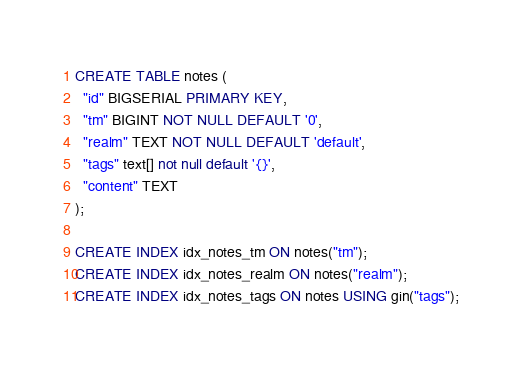<code> <loc_0><loc_0><loc_500><loc_500><_SQL_>CREATE TABLE notes (
  "id" BIGSERIAL PRIMARY KEY,
  "tm" BIGINT NOT NULL DEFAULT '0',
  "realm" TEXT NOT NULL DEFAULT 'default',
  "tags" text[] not null default '{}',
  "content" TEXT
);

CREATE INDEX idx_notes_tm ON notes("tm");
CREATE INDEX idx_notes_realm ON notes("realm");
CREATE INDEX idx_notes_tags ON notes USING gin("tags");

</code> 